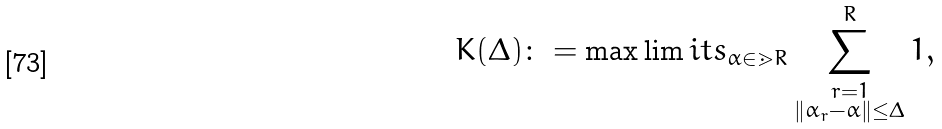<formula> <loc_0><loc_0><loc_500><loc_500>K ( \Delta ) \colon = \max \lim i t s _ { \alpha \in \mathbb { m } { R } } \sum _ { \substack { r = 1 \\ \| \alpha _ { r } - \alpha \| \leq \Delta } } ^ { R } 1 ,</formula> 